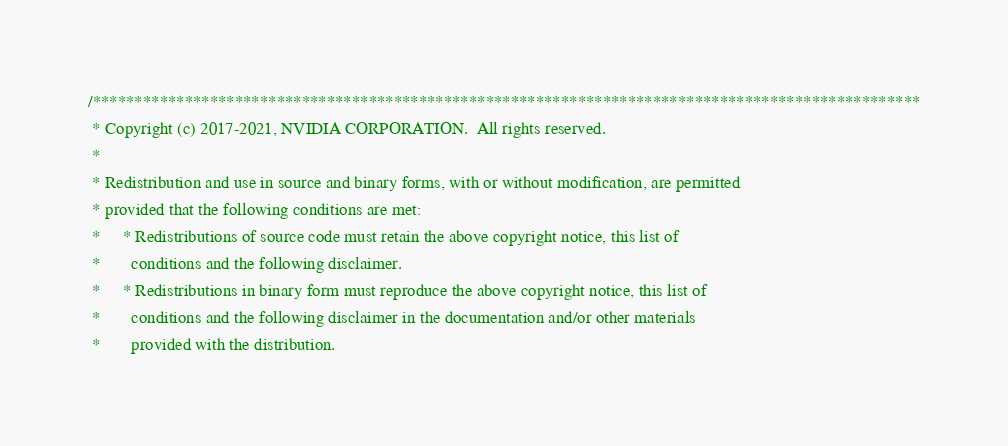Convert code to text. <code><loc_0><loc_0><loc_500><loc_500><_Cuda_>/***************************************************************************************************
 * Copyright (c) 2017-2021, NVIDIA CORPORATION.  All rights reserved.
 *
 * Redistribution and use in source and binary forms, with or without modification, are permitted
 * provided that the following conditions are met:
 *     * Redistributions of source code must retain the above copyright notice, this list of
 *       conditions and the following disclaimer.
 *     * Redistributions in binary form must reproduce the above copyright notice, this list of
 *       conditions and the following disclaimer in the documentation and/or other materials
 *       provided with the distribution.</code> 